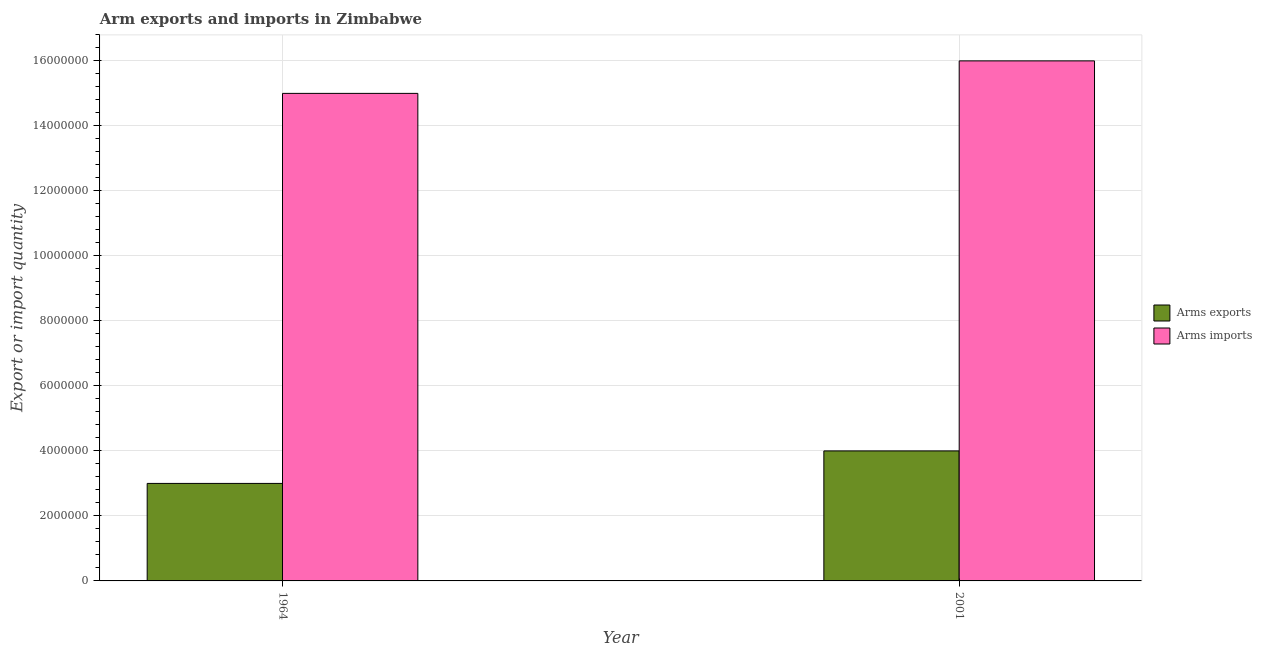How many different coloured bars are there?
Ensure brevity in your answer.  2. Are the number of bars per tick equal to the number of legend labels?
Give a very brief answer. Yes. What is the label of the 1st group of bars from the left?
Keep it short and to the point. 1964. What is the arms exports in 1964?
Your response must be concise. 3.00e+06. Across all years, what is the maximum arms imports?
Your answer should be compact. 1.60e+07. Across all years, what is the minimum arms imports?
Your response must be concise. 1.50e+07. In which year was the arms exports minimum?
Provide a short and direct response. 1964. What is the total arms exports in the graph?
Keep it short and to the point. 7.00e+06. What is the difference between the arms exports in 1964 and that in 2001?
Your answer should be very brief. -1.00e+06. What is the difference between the arms imports in 2001 and the arms exports in 1964?
Keep it short and to the point. 1.00e+06. What is the average arms imports per year?
Offer a very short reply. 1.55e+07. In the year 2001, what is the difference between the arms imports and arms exports?
Ensure brevity in your answer.  0. In how many years, is the arms exports greater than 15600000?
Offer a very short reply. 0. What is the ratio of the arms exports in 1964 to that in 2001?
Your response must be concise. 0.75. Is the arms imports in 1964 less than that in 2001?
Your answer should be very brief. Yes. What does the 2nd bar from the left in 2001 represents?
Your response must be concise. Arms imports. What does the 1st bar from the right in 1964 represents?
Your answer should be compact. Arms imports. Are all the bars in the graph horizontal?
Give a very brief answer. No. How many years are there in the graph?
Give a very brief answer. 2. What is the difference between two consecutive major ticks on the Y-axis?
Ensure brevity in your answer.  2.00e+06. Does the graph contain grids?
Your answer should be very brief. Yes. How many legend labels are there?
Offer a terse response. 2. How are the legend labels stacked?
Provide a short and direct response. Vertical. What is the title of the graph?
Your answer should be very brief. Arm exports and imports in Zimbabwe. Does "Non-solid fuel" appear as one of the legend labels in the graph?
Give a very brief answer. No. What is the label or title of the Y-axis?
Offer a terse response. Export or import quantity. What is the Export or import quantity in Arms imports in 1964?
Provide a short and direct response. 1.50e+07. What is the Export or import quantity in Arms exports in 2001?
Your answer should be compact. 4.00e+06. What is the Export or import quantity of Arms imports in 2001?
Your answer should be very brief. 1.60e+07. Across all years, what is the maximum Export or import quantity of Arms imports?
Make the answer very short. 1.60e+07. Across all years, what is the minimum Export or import quantity in Arms imports?
Your answer should be very brief. 1.50e+07. What is the total Export or import quantity in Arms exports in the graph?
Ensure brevity in your answer.  7.00e+06. What is the total Export or import quantity of Arms imports in the graph?
Provide a short and direct response. 3.10e+07. What is the difference between the Export or import quantity in Arms imports in 1964 and that in 2001?
Give a very brief answer. -1.00e+06. What is the difference between the Export or import quantity of Arms exports in 1964 and the Export or import quantity of Arms imports in 2001?
Your response must be concise. -1.30e+07. What is the average Export or import quantity in Arms exports per year?
Ensure brevity in your answer.  3.50e+06. What is the average Export or import quantity of Arms imports per year?
Offer a terse response. 1.55e+07. In the year 1964, what is the difference between the Export or import quantity in Arms exports and Export or import quantity in Arms imports?
Ensure brevity in your answer.  -1.20e+07. In the year 2001, what is the difference between the Export or import quantity of Arms exports and Export or import quantity of Arms imports?
Provide a succinct answer. -1.20e+07. What is the difference between the highest and the second highest Export or import quantity of Arms exports?
Offer a terse response. 1.00e+06. What is the difference between the highest and the second highest Export or import quantity in Arms imports?
Provide a short and direct response. 1.00e+06. 